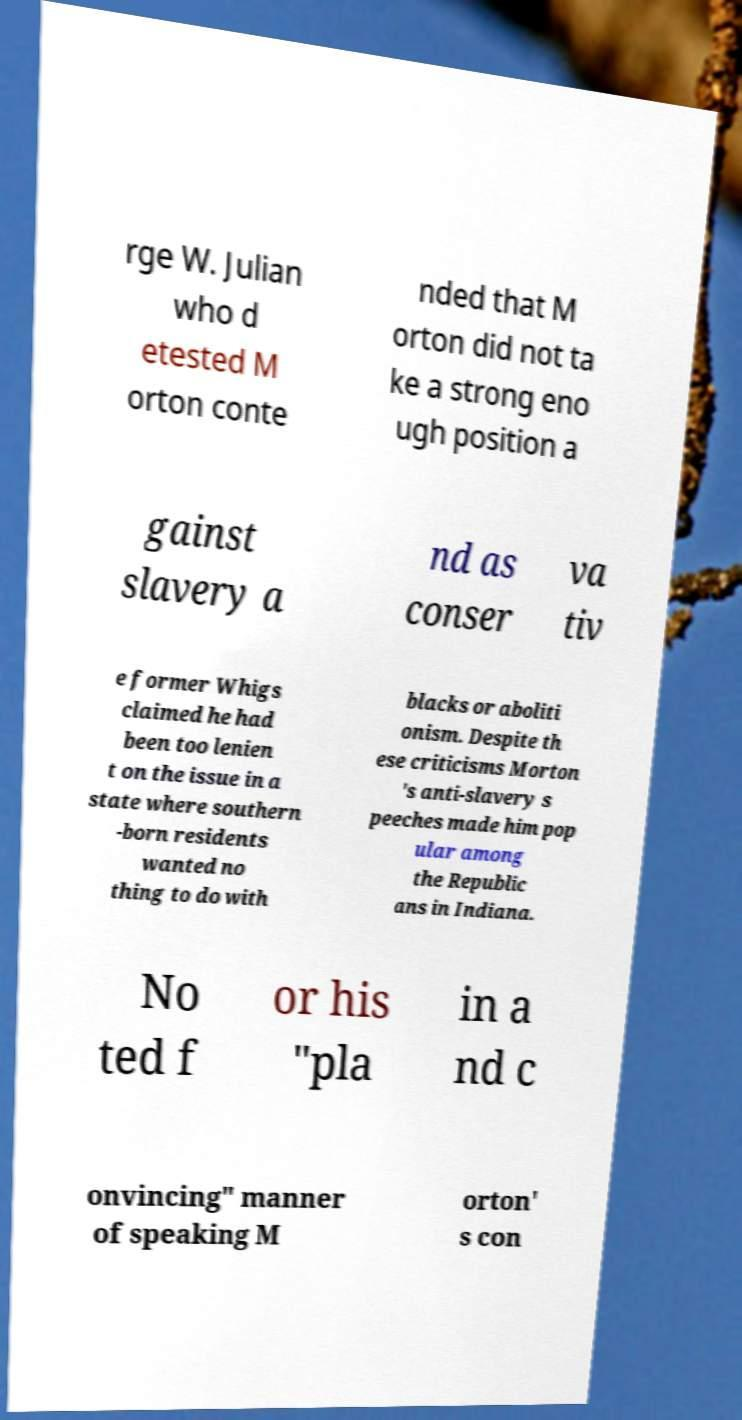Please identify and transcribe the text found in this image. rge W. Julian who d etested M orton conte nded that M orton did not ta ke a strong eno ugh position a gainst slavery a nd as conser va tiv e former Whigs claimed he had been too lenien t on the issue in a state where southern -born residents wanted no thing to do with blacks or aboliti onism. Despite th ese criticisms Morton 's anti-slavery s peeches made him pop ular among the Republic ans in Indiana. No ted f or his "pla in a nd c onvincing" manner of speaking M orton' s con 